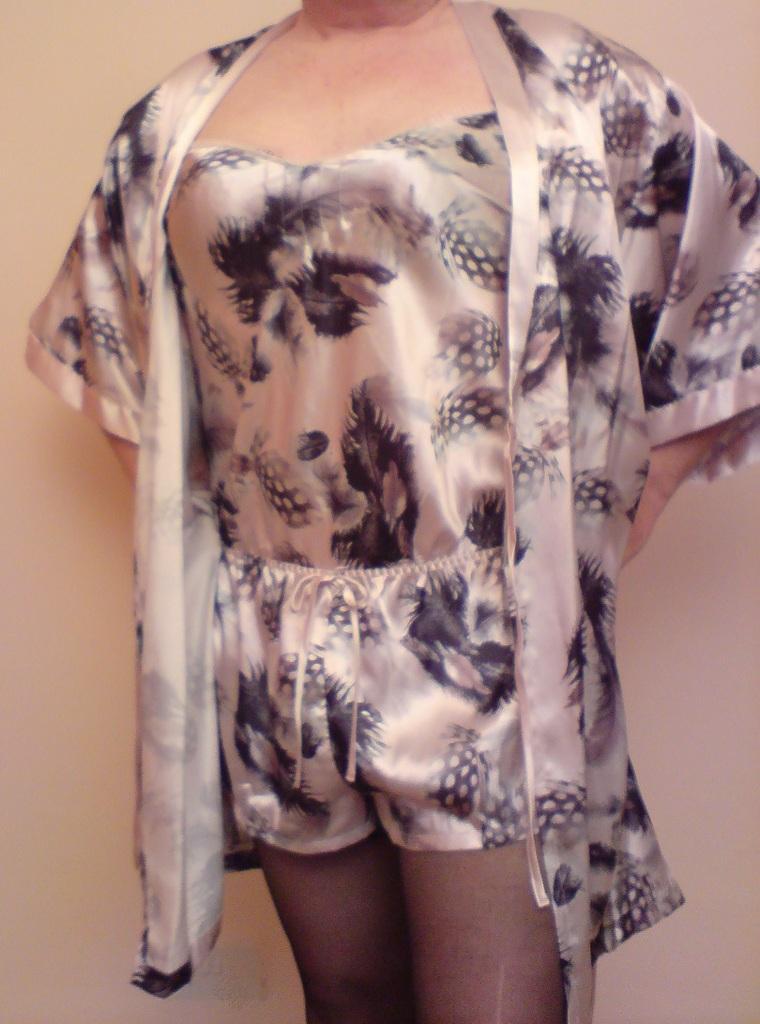Can you describe this image briefly? In this image I can see the person standing and the person is wearing cream and black color dress and I can see the cream color background. 